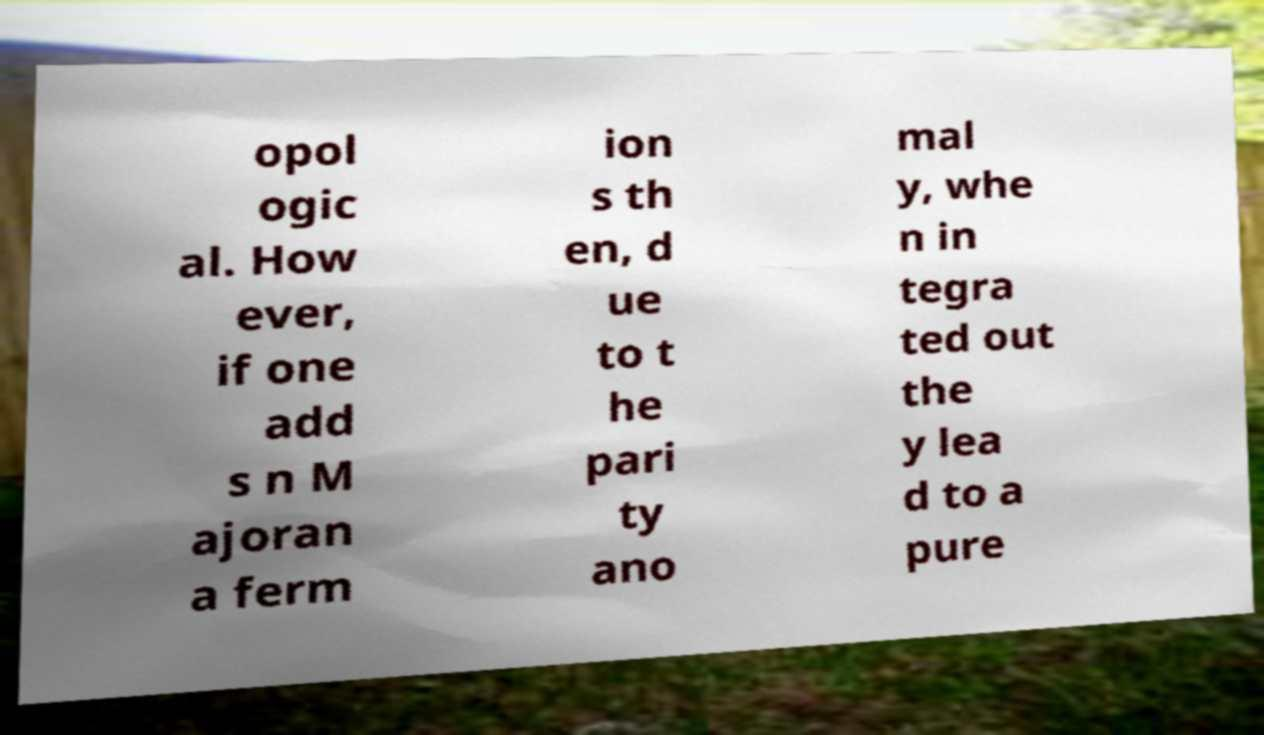What messages or text are displayed in this image? I need them in a readable, typed format. opol ogic al. How ever, if one add s n M ajoran a ferm ion s th en, d ue to t he pari ty ano mal y, whe n in tegra ted out the y lea d to a pure 